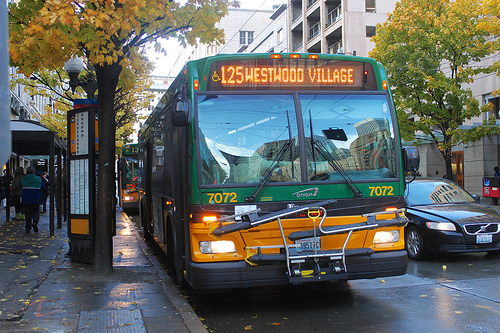How clean is this bus? The bus appears to be in a well-maintained and clean condition, reflecting an efficient urban public transport system. 